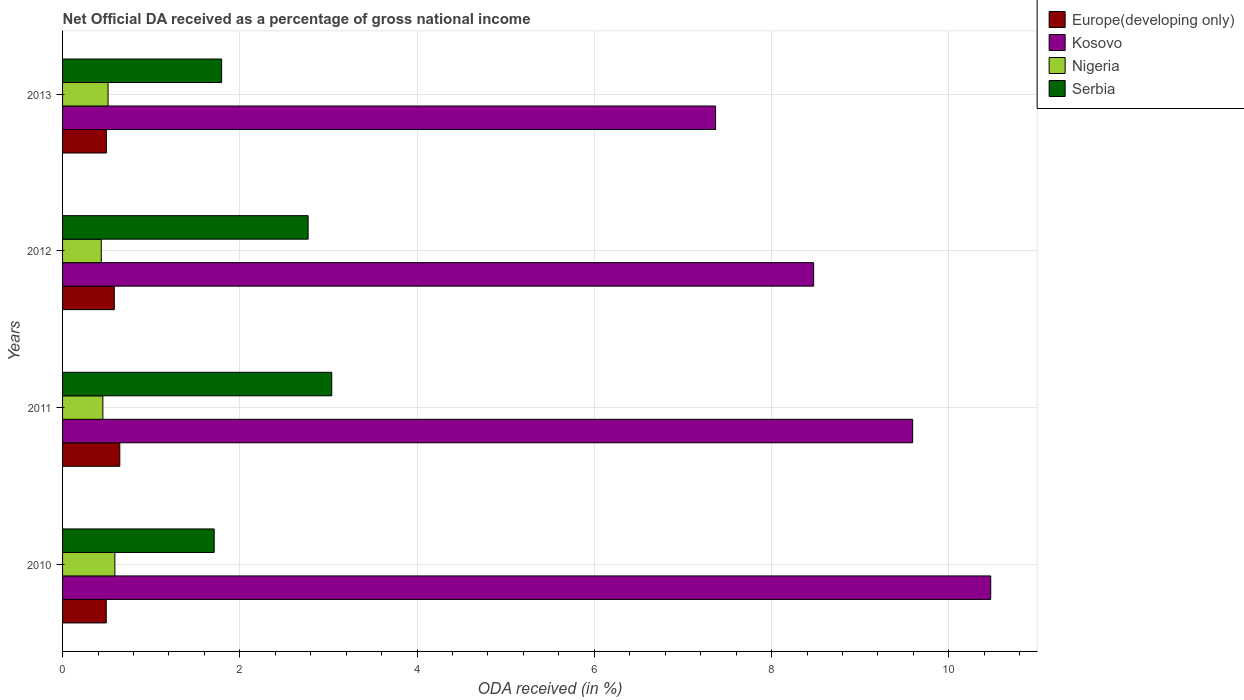Are the number of bars per tick equal to the number of legend labels?
Offer a very short reply. Yes. Are the number of bars on each tick of the Y-axis equal?
Your answer should be compact. Yes. How many bars are there on the 2nd tick from the top?
Your answer should be compact. 4. What is the label of the 2nd group of bars from the top?
Provide a succinct answer. 2012. In how many cases, is the number of bars for a given year not equal to the number of legend labels?
Your answer should be compact. 0. What is the net official DA received in Kosovo in 2012?
Offer a terse response. 8.47. Across all years, what is the maximum net official DA received in Europe(developing only)?
Your answer should be compact. 0.65. Across all years, what is the minimum net official DA received in Europe(developing only)?
Make the answer very short. 0.49. In which year was the net official DA received in Serbia minimum?
Keep it short and to the point. 2010. What is the total net official DA received in Kosovo in the graph?
Keep it short and to the point. 35.91. What is the difference between the net official DA received in Serbia in 2010 and that in 2013?
Provide a succinct answer. -0.08. What is the difference between the net official DA received in Kosovo in 2010 and the net official DA received in Nigeria in 2012?
Offer a very short reply. 10.04. What is the average net official DA received in Europe(developing only) per year?
Your response must be concise. 0.55. In the year 2013, what is the difference between the net official DA received in Serbia and net official DA received in Europe(developing only)?
Keep it short and to the point. 1.3. What is the ratio of the net official DA received in Kosovo in 2010 to that in 2013?
Make the answer very short. 1.42. Is the net official DA received in Europe(developing only) in 2012 less than that in 2013?
Make the answer very short. No. What is the difference between the highest and the second highest net official DA received in Europe(developing only)?
Ensure brevity in your answer.  0.06. What is the difference between the highest and the lowest net official DA received in Nigeria?
Keep it short and to the point. 0.15. Is the sum of the net official DA received in Europe(developing only) in 2011 and 2012 greater than the maximum net official DA received in Kosovo across all years?
Your response must be concise. No. Is it the case that in every year, the sum of the net official DA received in Europe(developing only) and net official DA received in Nigeria is greater than the sum of net official DA received in Kosovo and net official DA received in Serbia?
Offer a very short reply. No. What does the 4th bar from the top in 2013 represents?
Your response must be concise. Europe(developing only). What does the 2nd bar from the bottom in 2010 represents?
Make the answer very short. Kosovo. How many bars are there?
Your response must be concise. 16. Are all the bars in the graph horizontal?
Your answer should be very brief. Yes. What is the difference between two consecutive major ticks on the X-axis?
Provide a succinct answer. 2. Are the values on the major ticks of X-axis written in scientific E-notation?
Keep it short and to the point. No. Does the graph contain any zero values?
Keep it short and to the point. No. Does the graph contain grids?
Keep it short and to the point. Yes. Where does the legend appear in the graph?
Make the answer very short. Top right. How many legend labels are there?
Provide a succinct answer. 4. What is the title of the graph?
Keep it short and to the point. Net Official DA received as a percentage of gross national income. Does "French Polynesia" appear as one of the legend labels in the graph?
Keep it short and to the point. No. What is the label or title of the X-axis?
Offer a terse response. ODA received (in %). What is the label or title of the Y-axis?
Your response must be concise. Years. What is the ODA received (in %) of Europe(developing only) in 2010?
Offer a terse response. 0.49. What is the ODA received (in %) of Kosovo in 2010?
Provide a succinct answer. 10.47. What is the ODA received (in %) of Nigeria in 2010?
Provide a succinct answer. 0.59. What is the ODA received (in %) of Serbia in 2010?
Give a very brief answer. 1.71. What is the ODA received (in %) of Europe(developing only) in 2011?
Your answer should be compact. 0.65. What is the ODA received (in %) in Kosovo in 2011?
Offer a very short reply. 9.59. What is the ODA received (in %) of Nigeria in 2011?
Provide a succinct answer. 0.45. What is the ODA received (in %) in Serbia in 2011?
Provide a short and direct response. 3.04. What is the ODA received (in %) in Europe(developing only) in 2012?
Offer a very short reply. 0.58. What is the ODA received (in %) of Kosovo in 2012?
Ensure brevity in your answer.  8.47. What is the ODA received (in %) in Nigeria in 2012?
Give a very brief answer. 0.44. What is the ODA received (in %) in Serbia in 2012?
Make the answer very short. 2.77. What is the ODA received (in %) of Europe(developing only) in 2013?
Provide a succinct answer. 0.49. What is the ODA received (in %) of Kosovo in 2013?
Ensure brevity in your answer.  7.37. What is the ODA received (in %) of Nigeria in 2013?
Provide a short and direct response. 0.51. What is the ODA received (in %) of Serbia in 2013?
Keep it short and to the point. 1.79. Across all years, what is the maximum ODA received (in %) of Europe(developing only)?
Provide a succinct answer. 0.65. Across all years, what is the maximum ODA received (in %) of Kosovo?
Provide a short and direct response. 10.47. Across all years, what is the maximum ODA received (in %) of Nigeria?
Keep it short and to the point. 0.59. Across all years, what is the maximum ODA received (in %) of Serbia?
Provide a succinct answer. 3.04. Across all years, what is the minimum ODA received (in %) of Europe(developing only)?
Give a very brief answer. 0.49. Across all years, what is the minimum ODA received (in %) in Kosovo?
Provide a succinct answer. 7.37. Across all years, what is the minimum ODA received (in %) in Nigeria?
Your answer should be compact. 0.44. Across all years, what is the minimum ODA received (in %) in Serbia?
Give a very brief answer. 1.71. What is the total ODA received (in %) of Europe(developing only) in the graph?
Provide a short and direct response. 2.22. What is the total ODA received (in %) of Kosovo in the graph?
Offer a very short reply. 35.91. What is the total ODA received (in %) of Nigeria in the graph?
Ensure brevity in your answer.  2. What is the total ODA received (in %) of Serbia in the graph?
Your answer should be compact. 9.31. What is the difference between the ODA received (in %) of Europe(developing only) in 2010 and that in 2011?
Your answer should be very brief. -0.15. What is the difference between the ODA received (in %) of Kosovo in 2010 and that in 2011?
Keep it short and to the point. 0.88. What is the difference between the ODA received (in %) of Nigeria in 2010 and that in 2011?
Give a very brief answer. 0.14. What is the difference between the ODA received (in %) in Serbia in 2010 and that in 2011?
Your answer should be compact. -1.33. What is the difference between the ODA received (in %) of Europe(developing only) in 2010 and that in 2012?
Ensure brevity in your answer.  -0.09. What is the difference between the ODA received (in %) in Kosovo in 2010 and that in 2012?
Provide a succinct answer. 2. What is the difference between the ODA received (in %) in Nigeria in 2010 and that in 2012?
Give a very brief answer. 0.15. What is the difference between the ODA received (in %) in Serbia in 2010 and that in 2012?
Your response must be concise. -1.06. What is the difference between the ODA received (in %) of Europe(developing only) in 2010 and that in 2013?
Your response must be concise. -0. What is the difference between the ODA received (in %) in Kosovo in 2010 and that in 2013?
Ensure brevity in your answer.  3.1. What is the difference between the ODA received (in %) in Nigeria in 2010 and that in 2013?
Give a very brief answer. 0.08. What is the difference between the ODA received (in %) in Serbia in 2010 and that in 2013?
Your response must be concise. -0.08. What is the difference between the ODA received (in %) of Europe(developing only) in 2011 and that in 2012?
Offer a terse response. 0.06. What is the difference between the ODA received (in %) in Kosovo in 2011 and that in 2012?
Offer a terse response. 1.12. What is the difference between the ODA received (in %) in Nigeria in 2011 and that in 2012?
Provide a short and direct response. 0.02. What is the difference between the ODA received (in %) in Serbia in 2011 and that in 2012?
Provide a succinct answer. 0.27. What is the difference between the ODA received (in %) of Europe(developing only) in 2011 and that in 2013?
Give a very brief answer. 0.15. What is the difference between the ODA received (in %) in Kosovo in 2011 and that in 2013?
Your answer should be compact. 2.22. What is the difference between the ODA received (in %) of Nigeria in 2011 and that in 2013?
Keep it short and to the point. -0.06. What is the difference between the ODA received (in %) in Serbia in 2011 and that in 2013?
Your answer should be compact. 1.24. What is the difference between the ODA received (in %) of Europe(developing only) in 2012 and that in 2013?
Keep it short and to the point. 0.09. What is the difference between the ODA received (in %) in Kosovo in 2012 and that in 2013?
Provide a short and direct response. 1.11. What is the difference between the ODA received (in %) of Nigeria in 2012 and that in 2013?
Keep it short and to the point. -0.08. What is the difference between the ODA received (in %) in Serbia in 2012 and that in 2013?
Your response must be concise. 0.98. What is the difference between the ODA received (in %) in Europe(developing only) in 2010 and the ODA received (in %) in Kosovo in 2011?
Offer a very short reply. -9.1. What is the difference between the ODA received (in %) in Europe(developing only) in 2010 and the ODA received (in %) in Nigeria in 2011?
Your answer should be compact. 0.04. What is the difference between the ODA received (in %) in Europe(developing only) in 2010 and the ODA received (in %) in Serbia in 2011?
Ensure brevity in your answer.  -2.54. What is the difference between the ODA received (in %) in Kosovo in 2010 and the ODA received (in %) in Nigeria in 2011?
Give a very brief answer. 10.02. What is the difference between the ODA received (in %) in Kosovo in 2010 and the ODA received (in %) in Serbia in 2011?
Provide a succinct answer. 7.44. What is the difference between the ODA received (in %) of Nigeria in 2010 and the ODA received (in %) of Serbia in 2011?
Provide a succinct answer. -2.45. What is the difference between the ODA received (in %) of Europe(developing only) in 2010 and the ODA received (in %) of Kosovo in 2012?
Your response must be concise. -7.98. What is the difference between the ODA received (in %) of Europe(developing only) in 2010 and the ODA received (in %) of Nigeria in 2012?
Your answer should be very brief. 0.06. What is the difference between the ODA received (in %) in Europe(developing only) in 2010 and the ODA received (in %) in Serbia in 2012?
Your answer should be very brief. -2.28. What is the difference between the ODA received (in %) of Kosovo in 2010 and the ODA received (in %) of Nigeria in 2012?
Offer a terse response. 10.04. What is the difference between the ODA received (in %) of Kosovo in 2010 and the ODA received (in %) of Serbia in 2012?
Keep it short and to the point. 7.7. What is the difference between the ODA received (in %) of Nigeria in 2010 and the ODA received (in %) of Serbia in 2012?
Provide a short and direct response. -2.18. What is the difference between the ODA received (in %) in Europe(developing only) in 2010 and the ODA received (in %) in Kosovo in 2013?
Your response must be concise. -6.88. What is the difference between the ODA received (in %) of Europe(developing only) in 2010 and the ODA received (in %) of Nigeria in 2013?
Offer a terse response. -0.02. What is the difference between the ODA received (in %) of Europe(developing only) in 2010 and the ODA received (in %) of Serbia in 2013?
Your answer should be very brief. -1.3. What is the difference between the ODA received (in %) of Kosovo in 2010 and the ODA received (in %) of Nigeria in 2013?
Keep it short and to the point. 9.96. What is the difference between the ODA received (in %) of Kosovo in 2010 and the ODA received (in %) of Serbia in 2013?
Keep it short and to the point. 8.68. What is the difference between the ODA received (in %) in Nigeria in 2010 and the ODA received (in %) in Serbia in 2013?
Provide a short and direct response. -1.2. What is the difference between the ODA received (in %) in Europe(developing only) in 2011 and the ODA received (in %) in Kosovo in 2012?
Your answer should be compact. -7.83. What is the difference between the ODA received (in %) in Europe(developing only) in 2011 and the ODA received (in %) in Nigeria in 2012?
Provide a succinct answer. 0.21. What is the difference between the ODA received (in %) in Europe(developing only) in 2011 and the ODA received (in %) in Serbia in 2012?
Your answer should be very brief. -2.12. What is the difference between the ODA received (in %) of Kosovo in 2011 and the ODA received (in %) of Nigeria in 2012?
Your answer should be compact. 9.16. What is the difference between the ODA received (in %) of Kosovo in 2011 and the ODA received (in %) of Serbia in 2012?
Make the answer very short. 6.82. What is the difference between the ODA received (in %) in Nigeria in 2011 and the ODA received (in %) in Serbia in 2012?
Provide a succinct answer. -2.32. What is the difference between the ODA received (in %) in Europe(developing only) in 2011 and the ODA received (in %) in Kosovo in 2013?
Keep it short and to the point. -6.72. What is the difference between the ODA received (in %) of Europe(developing only) in 2011 and the ODA received (in %) of Nigeria in 2013?
Offer a very short reply. 0.13. What is the difference between the ODA received (in %) of Europe(developing only) in 2011 and the ODA received (in %) of Serbia in 2013?
Your response must be concise. -1.15. What is the difference between the ODA received (in %) in Kosovo in 2011 and the ODA received (in %) in Nigeria in 2013?
Provide a succinct answer. 9.08. What is the difference between the ODA received (in %) of Kosovo in 2011 and the ODA received (in %) of Serbia in 2013?
Your response must be concise. 7.8. What is the difference between the ODA received (in %) in Nigeria in 2011 and the ODA received (in %) in Serbia in 2013?
Provide a short and direct response. -1.34. What is the difference between the ODA received (in %) of Europe(developing only) in 2012 and the ODA received (in %) of Kosovo in 2013?
Give a very brief answer. -6.78. What is the difference between the ODA received (in %) of Europe(developing only) in 2012 and the ODA received (in %) of Nigeria in 2013?
Give a very brief answer. 0.07. What is the difference between the ODA received (in %) of Europe(developing only) in 2012 and the ODA received (in %) of Serbia in 2013?
Your response must be concise. -1.21. What is the difference between the ODA received (in %) in Kosovo in 2012 and the ODA received (in %) in Nigeria in 2013?
Provide a succinct answer. 7.96. What is the difference between the ODA received (in %) of Kosovo in 2012 and the ODA received (in %) of Serbia in 2013?
Your answer should be very brief. 6.68. What is the difference between the ODA received (in %) in Nigeria in 2012 and the ODA received (in %) in Serbia in 2013?
Provide a succinct answer. -1.36. What is the average ODA received (in %) in Europe(developing only) per year?
Give a very brief answer. 0.55. What is the average ODA received (in %) in Kosovo per year?
Your answer should be very brief. 8.98. What is the average ODA received (in %) of Nigeria per year?
Your answer should be compact. 0.5. What is the average ODA received (in %) in Serbia per year?
Provide a succinct answer. 2.33. In the year 2010, what is the difference between the ODA received (in %) in Europe(developing only) and ODA received (in %) in Kosovo?
Provide a succinct answer. -9.98. In the year 2010, what is the difference between the ODA received (in %) of Europe(developing only) and ODA received (in %) of Nigeria?
Offer a terse response. -0.1. In the year 2010, what is the difference between the ODA received (in %) in Europe(developing only) and ODA received (in %) in Serbia?
Keep it short and to the point. -1.22. In the year 2010, what is the difference between the ODA received (in %) of Kosovo and ODA received (in %) of Nigeria?
Offer a terse response. 9.88. In the year 2010, what is the difference between the ODA received (in %) in Kosovo and ODA received (in %) in Serbia?
Your response must be concise. 8.76. In the year 2010, what is the difference between the ODA received (in %) of Nigeria and ODA received (in %) of Serbia?
Your answer should be compact. -1.12. In the year 2011, what is the difference between the ODA received (in %) of Europe(developing only) and ODA received (in %) of Kosovo?
Keep it short and to the point. -8.95. In the year 2011, what is the difference between the ODA received (in %) of Europe(developing only) and ODA received (in %) of Nigeria?
Provide a succinct answer. 0.19. In the year 2011, what is the difference between the ODA received (in %) in Europe(developing only) and ODA received (in %) in Serbia?
Give a very brief answer. -2.39. In the year 2011, what is the difference between the ODA received (in %) of Kosovo and ODA received (in %) of Nigeria?
Provide a succinct answer. 9.14. In the year 2011, what is the difference between the ODA received (in %) of Kosovo and ODA received (in %) of Serbia?
Your answer should be compact. 6.55. In the year 2011, what is the difference between the ODA received (in %) in Nigeria and ODA received (in %) in Serbia?
Keep it short and to the point. -2.58. In the year 2012, what is the difference between the ODA received (in %) in Europe(developing only) and ODA received (in %) in Kosovo?
Your answer should be very brief. -7.89. In the year 2012, what is the difference between the ODA received (in %) in Europe(developing only) and ODA received (in %) in Nigeria?
Offer a very short reply. 0.15. In the year 2012, what is the difference between the ODA received (in %) in Europe(developing only) and ODA received (in %) in Serbia?
Make the answer very short. -2.19. In the year 2012, what is the difference between the ODA received (in %) in Kosovo and ODA received (in %) in Nigeria?
Provide a succinct answer. 8.04. In the year 2012, what is the difference between the ODA received (in %) in Kosovo and ODA received (in %) in Serbia?
Your answer should be compact. 5.7. In the year 2012, what is the difference between the ODA received (in %) in Nigeria and ODA received (in %) in Serbia?
Your answer should be very brief. -2.33. In the year 2013, what is the difference between the ODA received (in %) of Europe(developing only) and ODA received (in %) of Kosovo?
Provide a short and direct response. -6.87. In the year 2013, what is the difference between the ODA received (in %) in Europe(developing only) and ODA received (in %) in Nigeria?
Keep it short and to the point. -0.02. In the year 2013, what is the difference between the ODA received (in %) of Europe(developing only) and ODA received (in %) of Serbia?
Give a very brief answer. -1.3. In the year 2013, what is the difference between the ODA received (in %) in Kosovo and ODA received (in %) in Nigeria?
Provide a short and direct response. 6.85. In the year 2013, what is the difference between the ODA received (in %) in Kosovo and ODA received (in %) in Serbia?
Provide a short and direct response. 5.57. In the year 2013, what is the difference between the ODA received (in %) in Nigeria and ODA received (in %) in Serbia?
Provide a short and direct response. -1.28. What is the ratio of the ODA received (in %) of Europe(developing only) in 2010 to that in 2011?
Your answer should be very brief. 0.76. What is the ratio of the ODA received (in %) in Kosovo in 2010 to that in 2011?
Offer a terse response. 1.09. What is the ratio of the ODA received (in %) of Nigeria in 2010 to that in 2011?
Offer a terse response. 1.3. What is the ratio of the ODA received (in %) of Serbia in 2010 to that in 2011?
Give a very brief answer. 0.56. What is the ratio of the ODA received (in %) in Europe(developing only) in 2010 to that in 2012?
Make the answer very short. 0.84. What is the ratio of the ODA received (in %) in Kosovo in 2010 to that in 2012?
Your answer should be very brief. 1.24. What is the ratio of the ODA received (in %) of Nigeria in 2010 to that in 2012?
Give a very brief answer. 1.35. What is the ratio of the ODA received (in %) of Serbia in 2010 to that in 2012?
Your response must be concise. 0.62. What is the ratio of the ODA received (in %) of Kosovo in 2010 to that in 2013?
Keep it short and to the point. 1.42. What is the ratio of the ODA received (in %) in Nigeria in 2010 to that in 2013?
Make the answer very short. 1.15. What is the ratio of the ODA received (in %) in Serbia in 2010 to that in 2013?
Your answer should be very brief. 0.95. What is the ratio of the ODA received (in %) in Europe(developing only) in 2011 to that in 2012?
Give a very brief answer. 1.11. What is the ratio of the ODA received (in %) in Kosovo in 2011 to that in 2012?
Offer a very short reply. 1.13. What is the ratio of the ODA received (in %) of Nigeria in 2011 to that in 2012?
Keep it short and to the point. 1.04. What is the ratio of the ODA received (in %) of Serbia in 2011 to that in 2012?
Provide a succinct answer. 1.1. What is the ratio of the ODA received (in %) in Europe(developing only) in 2011 to that in 2013?
Provide a succinct answer. 1.31. What is the ratio of the ODA received (in %) of Kosovo in 2011 to that in 2013?
Make the answer very short. 1.3. What is the ratio of the ODA received (in %) in Nigeria in 2011 to that in 2013?
Your response must be concise. 0.89. What is the ratio of the ODA received (in %) of Serbia in 2011 to that in 2013?
Keep it short and to the point. 1.69. What is the ratio of the ODA received (in %) in Europe(developing only) in 2012 to that in 2013?
Ensure brevity in your answer.  1.18. What is the ratio of the ODA received (in %) of Kosovo in 2012 to that in 2013?
Make the answer very short. 1.15. What is the ratio of the ODA received (in %) of Nigeria in 2012 to that in 2013?
Your answer should be very brief. 0.85. What is the ratio of the ODA received (in %) in Serbia in 2012 to that in 2013?
Keep it short and to the point. 1.54. What is the difference between the highest and the second highest ODA received (in %) in Europe(developing only)?
Give a very brief answer. 0.06. What is the difference between the highest and the second highest ODA received (in %) of Kosovo?
Offer a very short reply. 0.88. What is the difference between the highest and the second highest ODA received (in %) of Nigeria?
Provide a succinct answer. 0.08. What is the difference between the highest and the second highest ODA received (in %) of Serbia?
Ensure brevity in your answer.  0.27. What is the difference between the highest and the lowest ODA received (in %) of Europe(developing only)?
Your answer should be very brief. 0.15. What is the difference between the highest and the lowest ODA received (in %) in Kosovo?
Keep it short and to the point. 3.1. What is the difference between the highest and the lowest ODA received (in %) of Nigeria?
Offer a very short reply. 0.15. What is the difference between the highest and the lowest ODA received (in %) of Serbia?
Keep it short and to the point. 1.33. 